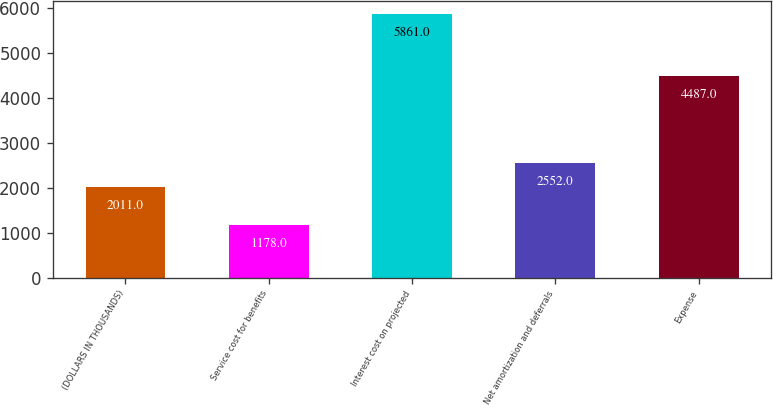<chart> <loc_0><loc_0><loc_500><loc_500><bar_chart><fcel>(DOLLARS IN THOUSANDS)<fcel>Service cost for benefits<fcel>Interest cost on projected<fcel>Net amortization and deferrals<fcel>Expense<nl><fcel>2011<fcel>1178<fcel>5861<fcel>2552<fcel>4487<nl></chart> 